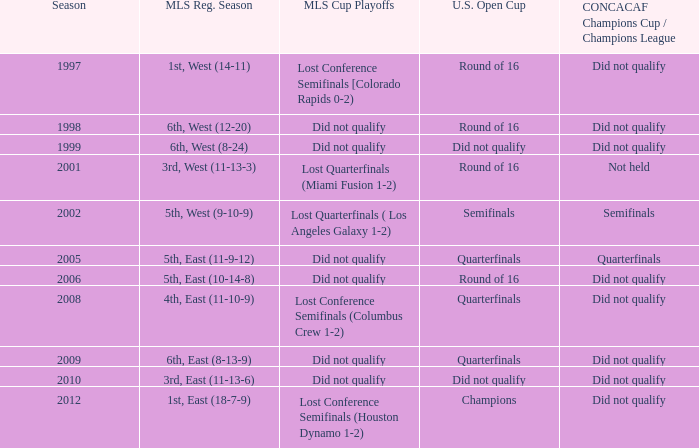What were the team's positions in the regular season when they advanced to the quarterfinals in the u.s. open cup but failed to qualify for the concaf champions cup? 4th, East (11-10-9), 6th, East (8-13-9). 